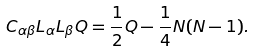Convert formula to latex. <formula><loc_0><loc_0><loc_500><loc_500>C _ { \alpha \beta } L _ { \alpha } L _ { \beta } Q = \frac { 1 } { 2 } Q - \frac { 1 } { 4 } N ( N - 1 ) .</formula> 